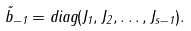Convert formula to latex. <formula><loc_0><loc_0><loc_500><loc_500>\tilde { b } _ { - 1 } = { d i a g } ( J _ { 1 } , J _ { 2 } , \dots , J _ { s - 1 } ) .</formula> 